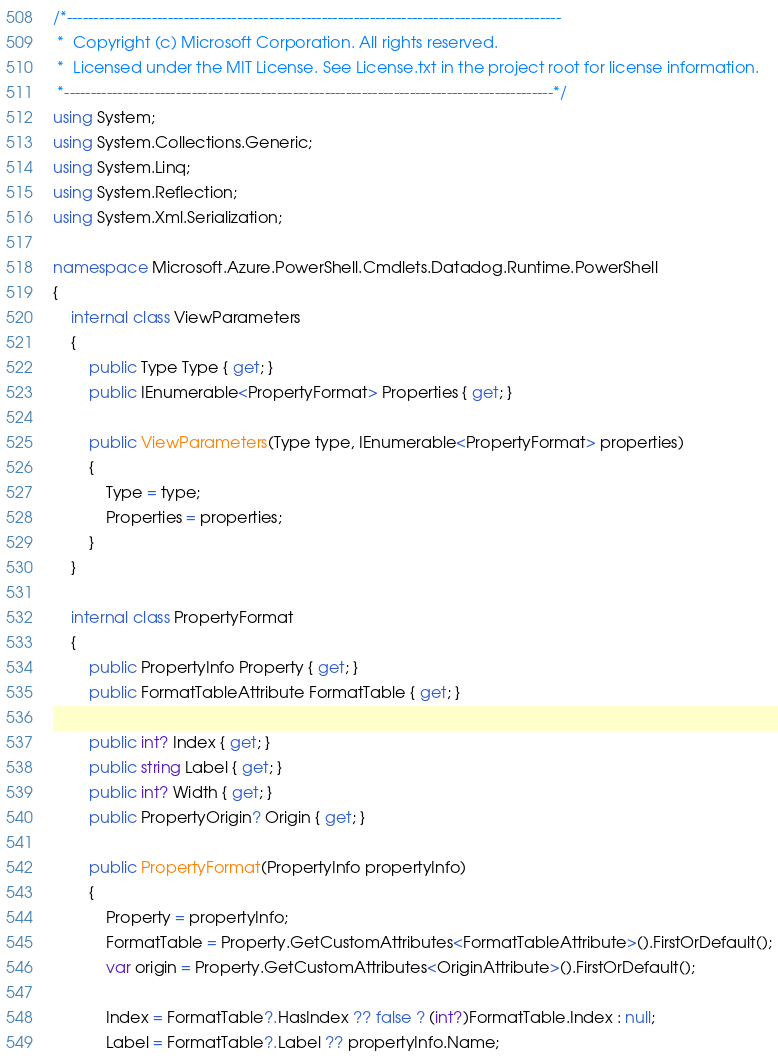<code> <loc_0><loc_0><loc_500><loc_500><_C#_>/*---------------------------------------------------------------------------------------------
 *  Copyright (c) Microsoft Corporation. All rights reserved.
 *  Licensed under the MIT License. See License.txt in the project root for license information.
 *--------------------------------------------------------------------------------------------*/
using System;
using System.Collections.Generic;
using System.Linq;
using System.Reflection;
using System.Xml.Serialization;

namespace Microsoft.Azure.PowerShell.Cmdlets.Datadog.Runtime.PowerShell
{
    internal class ViewParameters
    {
        public Type Type { get; }
        public IEnumerable<PropertyFormat> Properties { get; }

        public ViewParameters(Type type, IEnumerable<PropertyFormat> properties)
        {
            Type = type;
            Properties = properties;
        }
    }

    internal class PropertyFormat
    {
        public PropertyInfo Property { get; }
        public FormatTableAttribute FormatTable { get; }

        public int? Index { get; }
        public string Label { get; }
        public int? Width { get; }
        public PropertyOrigin? Origin { get; }

        public PropertyFormat(PropertyInfo propertyInfo)
        {
            Property = propertyInfo;
            FormatTable = Property.GetCustomAttributes<FormatTableAttribute>().FirstOrDefault();
            var origin = Property.GetCustomAttributes<OriginAttribute>().FirstOrDefault();

            Index = FormatTable?.HasIndex ?? false ? (int?)FormatTable.Index : null;
            Label = FormatTable?.Label ?? propertyInfo.Name;</code> 